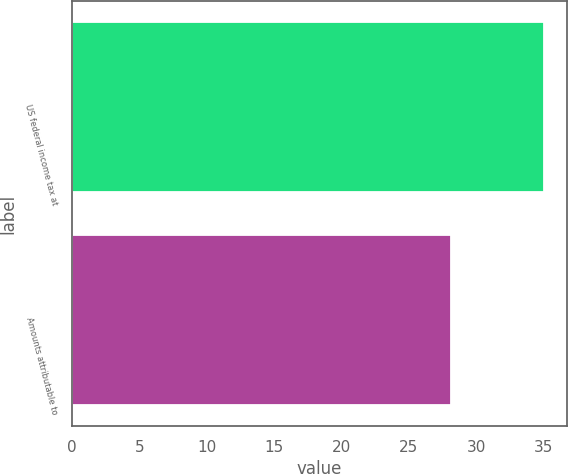<chart> <loc_0><loc_0><loc_500><loc_500><bar_chart><fcel>US federal income tax at<fcel>Amounts attributable to<nl><fcel>35<fcel>28.1<nl></chart> 